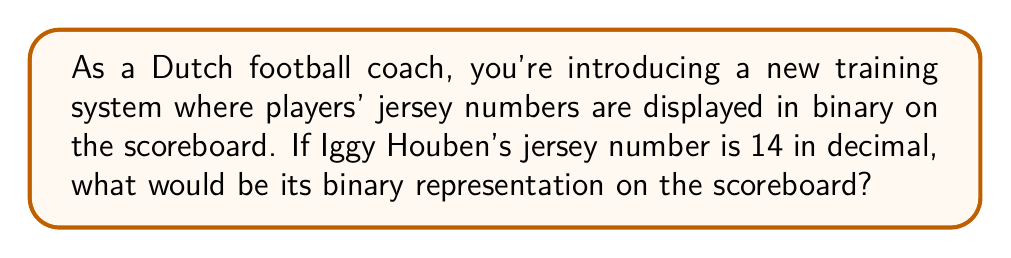Solve this math problem. To convert a decimal number to binary, we follow these steps:

1. Divide the decimal number by 2 repeatedly.
2. Keep track of the remainders in reverse order.
3. The remainders form the binary number.

Let's convert 14 to binary:

$$ 14 \div 2 = 7 \text{ remainder } 0 $$
$$ 7 \div 2 = 3 \text{ remainder } 1 $$
$$ 3 \div 2 = 1 \text{ remainder } 1 $$
$$ 1 \div 2 = 0 \text{ remainder } 1 $$

Reading the remainders from bottom to top, we get:

$$ 14_{10} = 1110_2 $$

To verify:

$$ 1\cdot2^3 + 1\cdot2^2 + 1\cdot2^1 + 0\cdot2^0 = 8 + 4 + 2 + 0 = 14 $$

Therefore, Iggy Houben's jersey number 14 would be displayed as 1110 in binary on the scoreboard.
Answer: $1110_2$ 